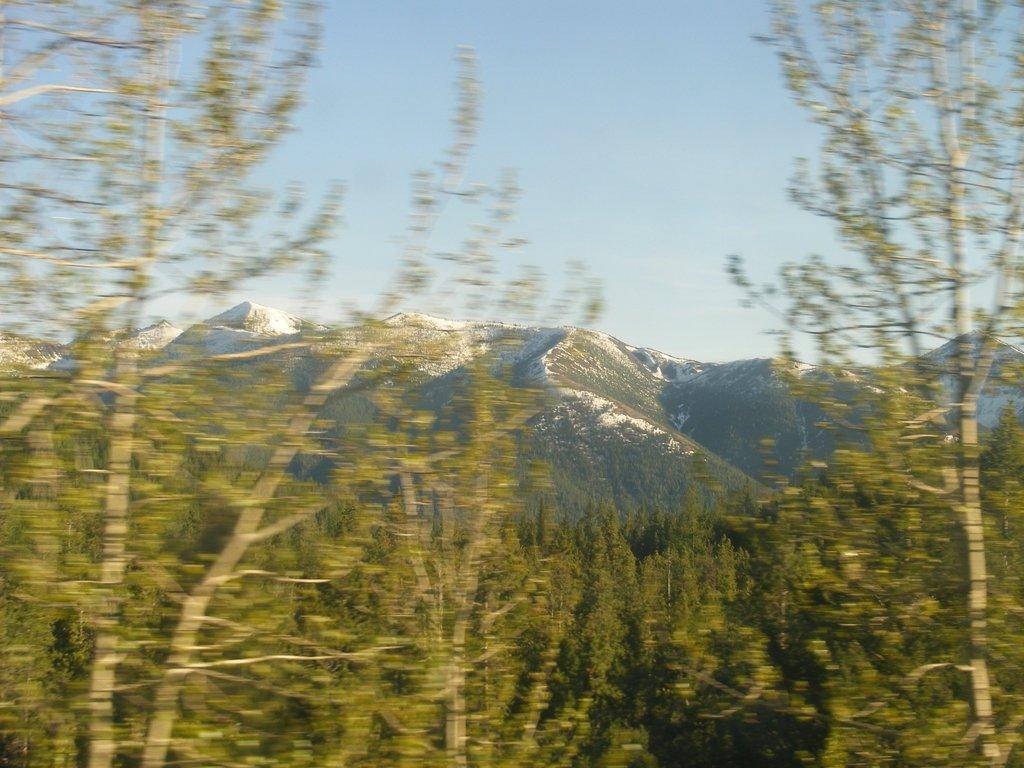Describe this image in one or two sentences. In this picture we can see trees, mountains and in the background we can see the sky. 